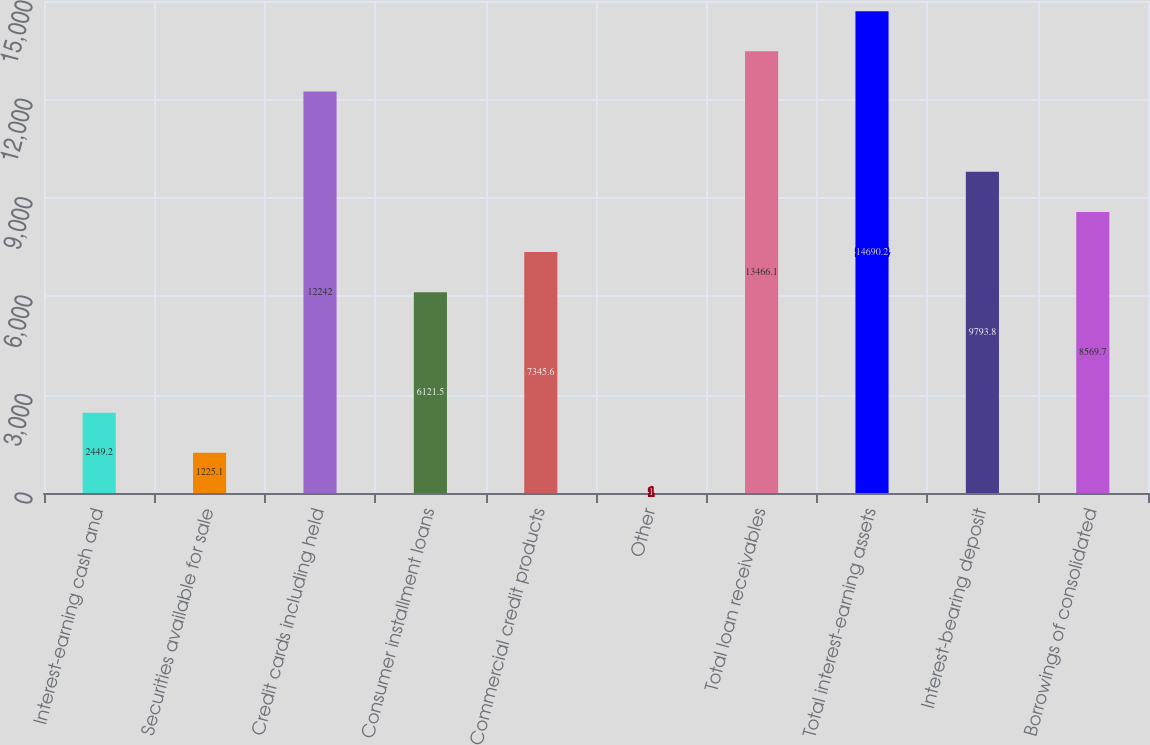<chart> <loc_0><loc_0><loc_500><loc_500><bar_chart><fcel>Interest-earning cash and<fcel>Securities available for sale<fcel>Credit cards including held<fcel>Consumer installment loans<fcel>Commercial credit products<fcel>Other<fcel>Total loan receivables<fcel>Total interest-earning assets<fcel>Interest-bearing deposit<fcel>Borrowings of consolidated<nl><fcel>2449.2<fcel>1225.1<fcel>12242<fcel>6121.5<fcel>7345.6<fcel>1<fcel>13466.1<fcel>14690.2<fcel>9793.8<fcel>8569.7<nl></chart> 